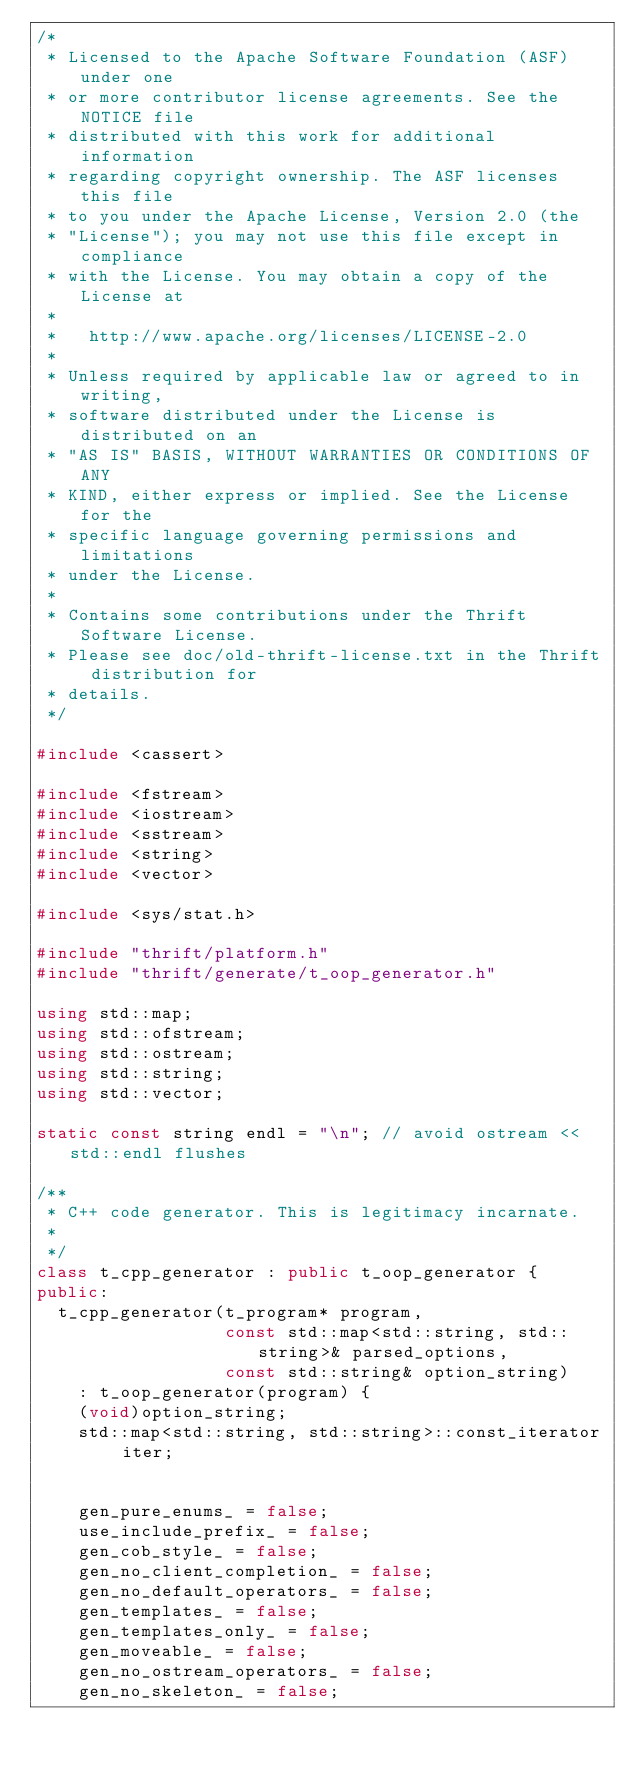Convert code to text. <code><loc_0><loc_0><loc_500><loc_500><_C++_>/*
 * Licensed to the Apache Software Foundation (ASF) under one
 * or more contributor license agreements. See the NOTICE file
 * distributed with this work for additional information
 * regarding copyright ownership. The ASF licenses this file
 * to you under the Apache License, Version 2.0 (the
 * "License"); you may not use this file except in compliance
 * with the License. You may obtain a copy of the License at
 *
 *   http://www.apache.org/licenses/LICENSE-2.0
 *
 * Unless required by applicable law or agreed to in writing,
 * software distributed under the License is distributed on an
 * "AS IS" BASIS, WITHOUT WARRANTIES OR CONDITIONS OF ANY
 * KIND, either express or implied. See the License for the
 * specific language governing permissions and limitations
 * under the License.
 *
 * Contains some contributions under the Thrift Software License.
 * Please see doc/old-thrift-license.txt in the Thrift distribution for
 * details.
 */

#include <cassert>

#include <fstream>
#include <iostream>
#include <sstream>
#include <string>
#include <vector>

#include <sys/stat.h>

#include "thrift/platform.h"
#include "thrift/generate/t_oop_generator.h"

using std::map;
using std::ofstream;
using std::ostream;
using std::string;
using std::vector;

static const string endl = "\n"; // avoid ostream << std::endl flushes

/**
 * C++ code generator. This is legitimacy incarnate.
 *
 */
class t_cpp_generator : public t_oop_generator {
public:
  t_cpp_generator(t_program* program,
                  const std::map<std::string, std::string>& parsed_options,
                  const std::string& option_string)
    : t_oop_generator(program) {
    (void)option_string;
    std::map<std::string, std::string>::const_iterator iter;


    gen_pure_enums_ = false;
    use_include_prefix_ = false;
    gen_cob_style_ = false;
    gen_no_client_completion_ = false;
    gen_no_default_operators_ = false;
    gen_templates_ = false;
    gen_templates_only_ = false;
    gen_moveable_ = false;
    gen_no_ostream_operators_ = false;
    gen_no_skeleton_ = false;
</code> 